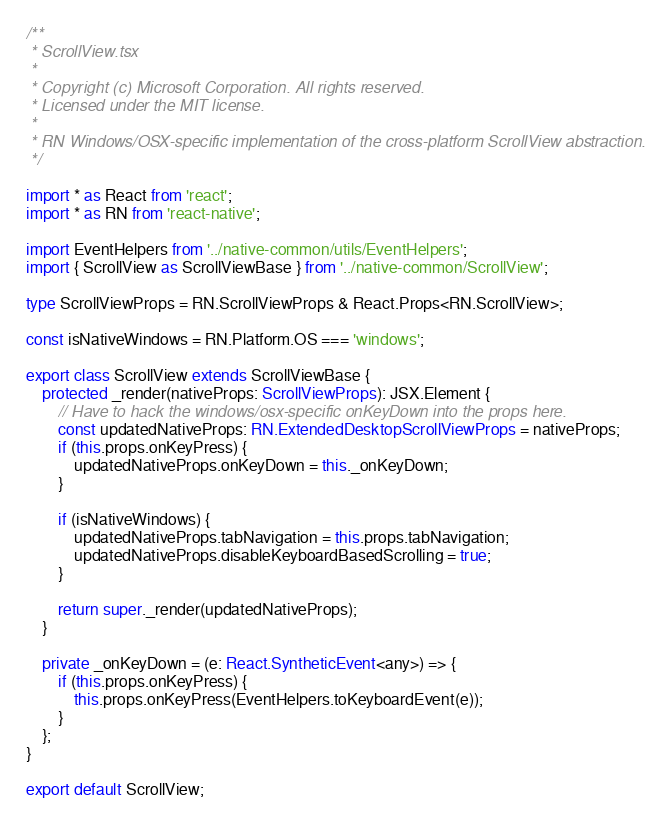<code> <loc_0><loc_0><loc_500><loc_500><_TypeScript_>/**
 * ScrollView.tsx
 *
 * Copyright (c) Microsoft Corporation. All rights reserved.
 * Licensed under the MIT license.
 *
 * RN Windows/OSX-specific implementation of the cross-platform ScrollView abstraction.
 */

import * as React from 'react';
import * as RN from 'react-native';

import EventHelpers from '../native-common/utils/EventHelpers';
import { ScrollView as ScrollViewBase } from '../native-common/ScrollView';

type ScrollViewProps = RN.ScrollViewProps & React.Props<RN.ScrollView>;

const isNativeWindows = RN.Platform.OS === 'windows';

export class ScrollView extends ScrollViewBase {
    protected _render(nativeProps: ScrollViewProps): JSX.Element {
        // Have to hack the windows/osx-specific onKeyDown into the props here.
        const updatedNativeProps: RN.ExtendedDesktopScrollViewProps = nativeProps;
        if (this.props.onKeyPress) {
            updatedNativeProps.onKeyDown = this._onKeyDown;
        }

        if (isNativeWindows) {
            updatedNativeProps.tabNavigation = this.props.tabNavigation;
            updatedNativeProps.disableKeyboardBasedScrolling = true;
        }

        return super._render(updatedNativeProps);
    }

    private _onKeyDown = (e: React.SyntheticEvent<any>) => {
        if (this.props.onKeyPress) {
            this.props.onKeyPress(EventHelpers.toKeyboardEvent(e));
        }
    };
}

export default ScrollView;
</code> 